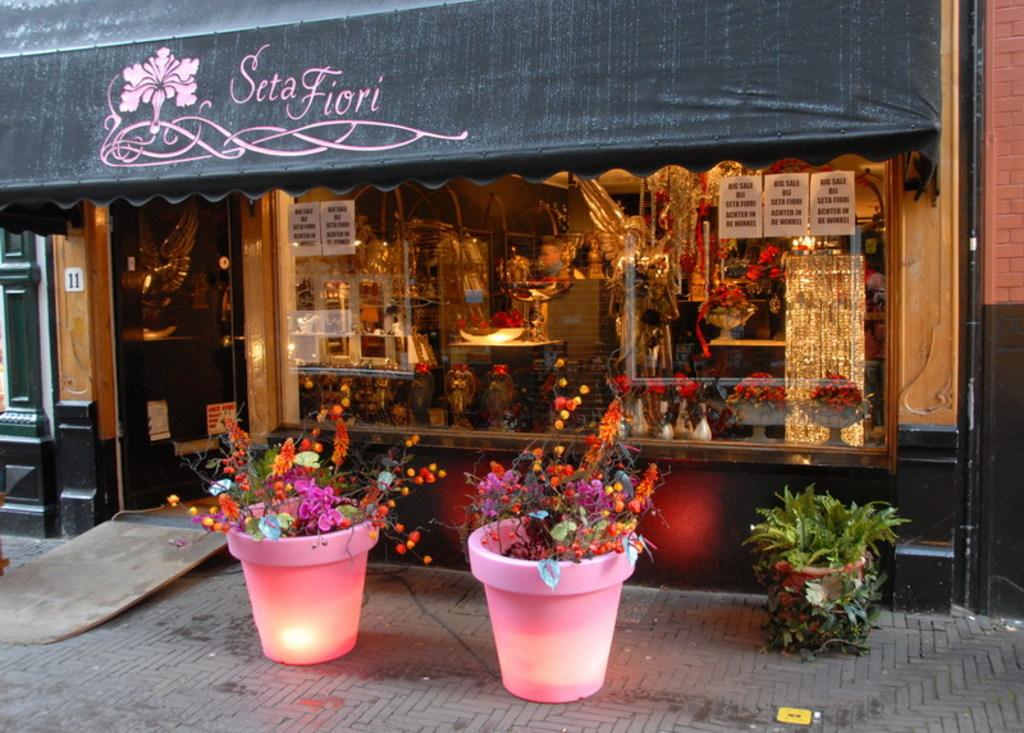What type of plants can be seen in the image? There are house plants in the image. What is visible behind the plants? There is a shop visible behind the plants. What can be found inside the shop? There are items present in the shop. How does the umbrella twist in the image? There is no umbrella present in the image, so it cannot twist. 